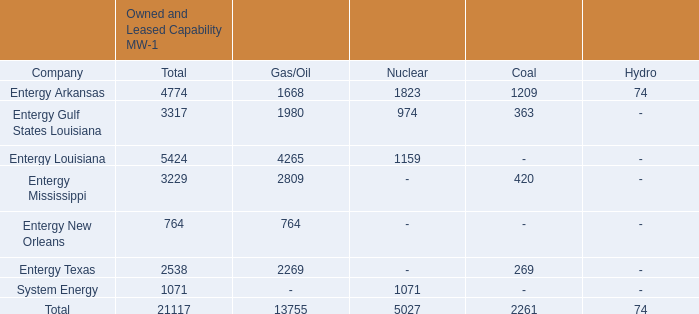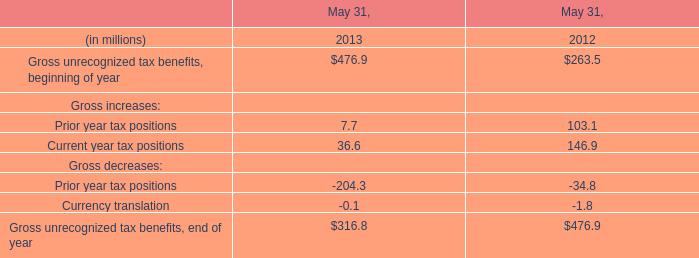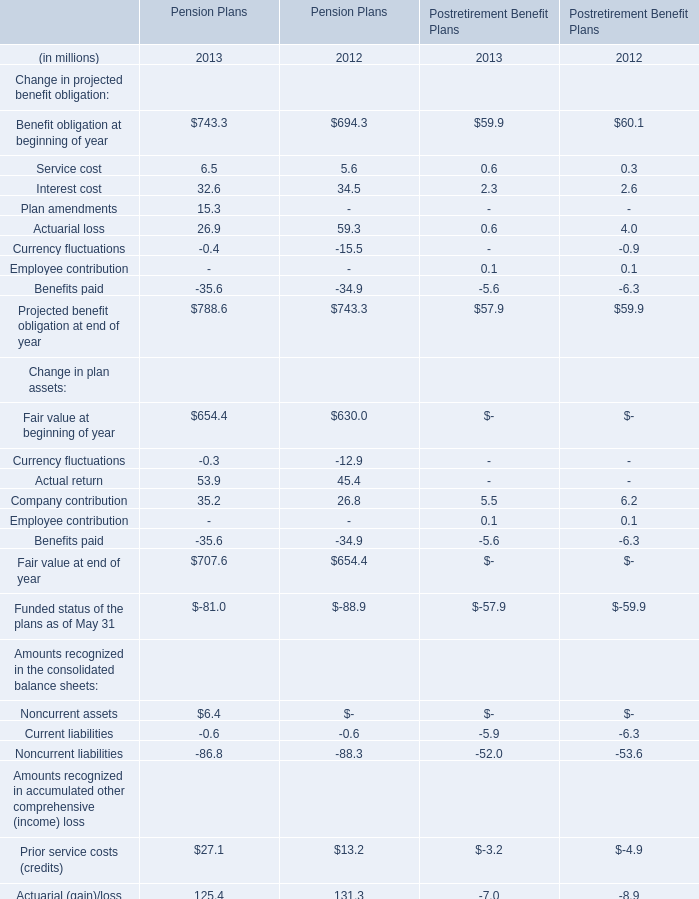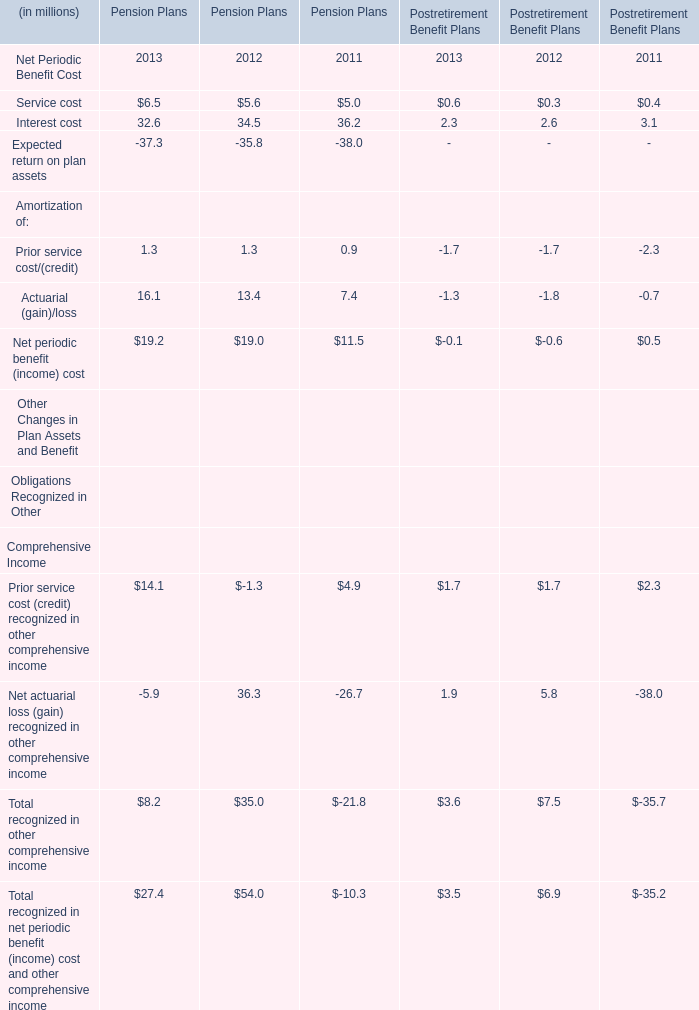What was the total amount of Postretirement Benefit Plans in the range of 0 and 1 in 2013? (in million) 
Computations: (((0.6 + 0.6) + 0.1) + 0.1)
Answer: 1.4. 